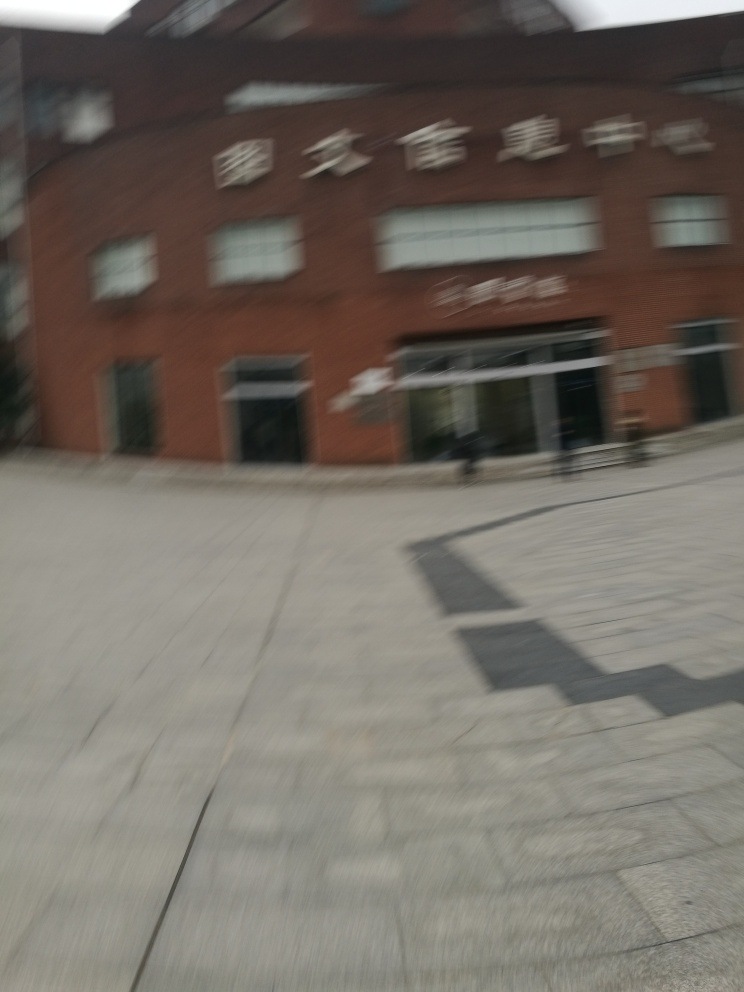What is the overall clarity of this image?
A. High
B. Extremely low
C. Average
D. Excellent The overall clarity of this image is indeed low, with noticeable blurring and lack of sharpness that makes it difficult to discern fine details. It appears that the camera was moving during the shot, or the settings were not adjusted correctly for the conditions, resulting in a photograph that lacks the clear definition that would be present in a high-clarity image. 